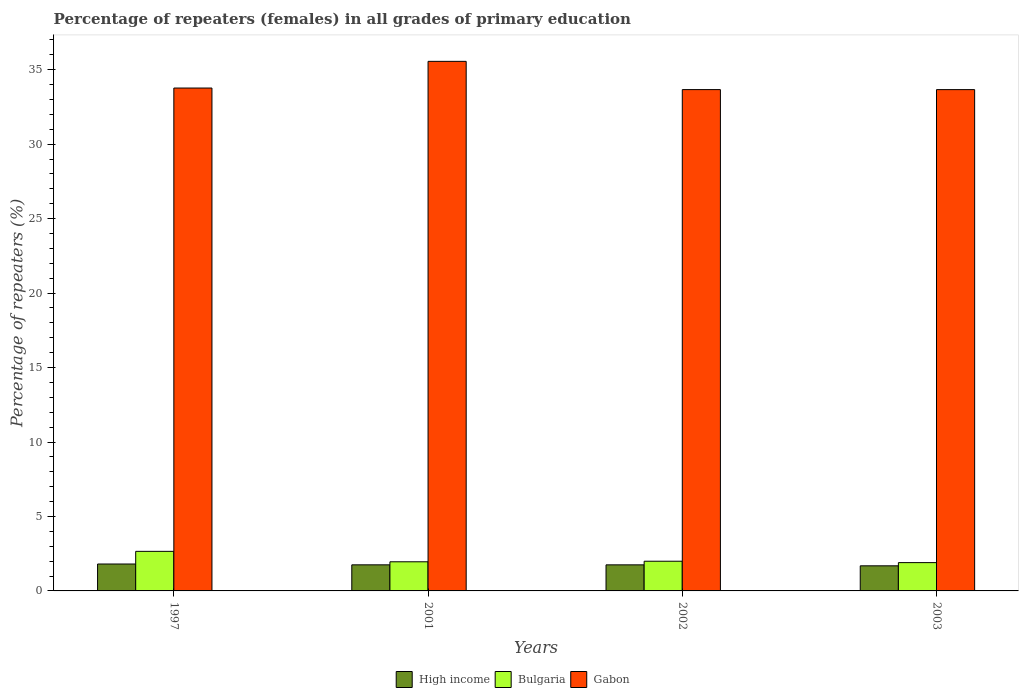How many different coloured bars are there?
Provide a succinct answer. 3. How many groups of bars are there?
Your response must be concise. 4. Are the number of bars on each tick of the X-axis equal?
Your answer should be very brief. Yes. How many bars are there on the 1st tick from the left?
Your answer should be compact. 3. What is the label of the 1st group of bars from the left?
Your answer should be very brief. 1997. What is the percentage of repeaters (females) in Gabon in 2002?
Ensure brevity in your answer.  33.66. Across all years, what is the maximum percentage of repeaters (females) in Bulgaria?
Provide a short and direct response. 2.66. Across all years, what is the minimum percentage of repeaters (females) in Bulgaria?
Provide a succinct answer. 1.9. In which year was the percentage of repeaters (females) in Bulgaria maximum?
Provide a short and direct response. 1997. In which year was the percentage of repeaters (females) in Gabon minimum?
Offer a very short reply. 2003. What is the total percentage of repeaters (females) in High income in the graph?
Provide a succinct answer. 6.99. What is the difference between the percentage of repeaters (females) in Bulgaria in 2001 and that in 2003?
Provide a short and direct response. 0.06. What is the difference between the percentage of repeaters (females) in Gabon in 1997 and the percentage of repeaters (females) in Bulgaria in 2002?
Offer a terse response. 31.77. What is the average percentage of repeaters (females) in Gabon per year?
Offer a terse response. 34.16. In the year 1997, what is the difference between the percentage of repeaters (females) in Bulgaria and percentage of repeaters (females) in High income?
Your answer should be very brief. 0.85. In how many years, is the percentage of repeaters (females) in Bulgaria greater than 9 %?
Offer a terse response. 0. What is the ratio of the percentage of repeaters (females) in Bulgaria in 1997 to that in 2002?
Provide a succinct answer. 1.33. Is the percentage of repeaters (females) in Bulgaria in 2001 less than that in 2003?
Your answer should be very brief. No. What is the difference between the highest and the second highest percentage of repeaters (females) in Gabon?
Ensure brevity in your answer.  1.79. What is the difference between the highest and the lowest percentage of repeaters (females) in Gabon?
Keep it short and to the point. 1.9. In how many years, is the percentage of repeaters (females) in Gabon greater than the average percentage of repeaters (females) in Gabon taken over all years?
Make the answer very short. 1. Is the sum of the percentage of repeaters (females) in Gabon in 2001 and 2002 greater than the maximum percentage of repeaters (females) in Bulgaria across all years?
Provide a short and direct response. Yes. What does the 3rd bar from the left in 2002 represents?
Provide a short and direct response. Gabon. What does the 1st bar from the right in 2002 represents?
Give a very brief answer. Gabon. Are all the bars in the graph horizontal?
Offer a very short reply. No. What is the difference between two consecutive major ticks on the Y-axis?
Your answer should be very brief. 5. Are the values on the major ticks of Y-axis written in scientific E-notation?
Provide a succinct answer. No. Does the graph contain grids?
Keep it short and to the point. No. What is the title of the graph?
Ensure brevity in your answer.  Percentage of repeaters (females) in all grades of primary education. What is the label or title of the Y-axis?
Offer a very short reply. Percentage of repeaters (%). What is the Percentage of repeaters (%) in High income in 1997?
Your answer should be very brief. 1.81. What is the Percentage of repeaters (%) in Bulgaria in 1997?
Your answer should be compact. 2.66. What is the Percentage of repeaters (%) in Gabon in 1997?
Offer a terse response. 33.77. What is the Percentage of repeaters (%) of High income in 2001?
Your response must be concise. 1.75. What is the Percentage of repeaters (%) in Bulgaria in 2001?
Provide a succinct answer. 1.96. What is the Percentage of repeaters (%) of Gabon in 2001?
Provide a short and direct response. 35.56. What is the Percentage of repeaters (%) in High income in 2002?
Give a very brief answer. 1.75. What is the Percentage of repeaters (%) in Bulgaria in 2002?
Offer a terse response. 1.99. What is the Percentage of repeaters (%) in Gabon in 2002?
Make the answer very short. 33.66. What is the Percentage of repeaters (%) in High income in 2003?
Offer a terse response. 1.69. What is the Percentage of repeaters (%) in Bulgaria in 2003?
Make the answer very short. 1.9. What is the Percentage of repeaters (%) of Gabon in 2003?
Make the answer very short. 33.66. Across all years, what is the maximum Percentage of repeaters (%) of High income?
Provide a short and direct response. 1.81. Across all years, what is the maximum Percentage of repeaters (%) of Bulgaria?
Give a very brief answer. 2.66. Across all years, what is the maximum Percentage of repeaters (%) of Gabon?
Offer a terse response. 35.56. Across all years, what is the minimum Percentage of repeaters (%) of High income?
Give a very brief answer. 1.69. Across all years, what is the minimum Percentage of repeaters (%) in Bulgaria?
Offer a terse response. 1.9. Across all years, what is the minimum Percentage of repeaters (%) in Gabon?
Your answer should be compact. 33.66. What is the total Percentage of repeaters (%) of High income in the graph?
Your response must be concise. 6.99. What is the total Percentage of repeaters (%) of Bulgaria in the graph?
Provide a short and direct response. 8.51. What is the total Percentage of repeaters (%) of Gabon in the graph?
Provide a short and direct response. 136.66. What is the difference between the Percentage of repeaters (%) of High income in 1997 and that in 2001?
Keep it short and to the point. 0.06. What is the difference between the Percentage of repeaters (%) in Bulgaria in 1997 and that in 2001?
Your answer should be very brief. 0.7. What is the difference between the Percentage of repeaters (%) of Gabon in 1997 and that in 2001?
Offer a terse response. -1.79. What is the difference between the Percentage of repeaters (%) in High income in 1997 and that in 2002?
Your answer should be compact. 0.06. What is the difference between the Percentage of repeaters (%) of Bulgaria in 1997 and that in 2002?
Your answer should be very brief. 0.66. What is the difference between the Percentage of repeaters (%) of Gabon in 1997 and that in 2002?
Offer a terse response. 0.1. What is the difference between the Percentage of repeaters (%) of High income in 1997 and that in 2003?
Make the answer very short. 0.12. What is the difference between the Percentage of repeaters (%) of Bulgaria in 1997 and that in 2003?
Offer a very short reply. 0.76. What is the difference between the Percentage of repeaters (%) of Gabon in 1997 and that in 2003?
Keep it short and to the point. 0.11. What is the difference between the Percentage of repeaters (%) of High income in 2001 and that in 2002?
Make the answer very short. 0. What is the difference between the Percentage of repeaters (%) of Bulgaria in 2001 and that in 2002?
Your answer should be compact. -0.04. What is the difference between the Percentage of repeaters (%) of Gabon in 2001 and that in 2002?
Offer a very short reply. 1.9. What is the difference between the Percentage of repeaters (%) in High income in 2001 and that in 2003?
Offer a terse response. 0.07. What is the difference between the Percentage of repeaters (%) in Bulgaria in 2001 and that in 2003?
Offer a terse response. 0.06. What is the difference between the Percentage of repeaters (%) of Gabon in 2001 and that in 2003?
Give a very brief answer. 1.9. What is the difference between the Percentage of repeaters (%) of High income in 2002 and that in 2003?
Offer a terse response. 0.06. What is the difference between the Percentage of repeaters (%) of Bulgaria in 2002 and that in 2003?
Your response must be concise. 0.09. What is the difference between the Percentage of repeaters (%) in Gabon in 2002 and that in 2003?
Offer a very short reply. 0. What is the difference between the Percentage of repeaters (%) in High income in 1997 and the Percentage of repeaters (%) in Bulgaria in 2001?
Ensure brevity in your answer.  -0.15. What is the difference between the Percentage of repeaters (%) of High income in 1997 and the Percentage of repeaters (%) of Gabon in 2001?
Give a very brief answer. -33.75. What is the difference between the Percentage of repeaters (%) of Bulgaria in 1997 and the Percentage of repeaters (%) of Gabon in 2001?
Your answer should be very brief. -32.9. What is the difference between the Percentage of repeaters (%) in High income in 1997 and the Percentage of repeaters (%) in Bulgaria in 2002?
Your answer should be compact. -0.19. What is the difference between the Percentage of repeaters (%) in High income in 1997 and the Percentage of repeaters (%) in Gabon in 2002?
Your answer should be compact. -31.86. What is the difference between the Percentage of repeaters (%) in Bulgaria in 1997 and the Percentage of repeaters (%) in Gabon in 2002?
Your answer should be compact. -31.01. What is the difference between the Percentage of repeaters (%) in High income in 1997 and the Percentage of repeaters (%) in Bulgaria in 2003?
Make the answer very short. -0.09. What is the difference between the Percentage of repeaters (%) in High income in 1997 and the Percentage of repeaters (%) in Gabon in 2003?
Offer a very short reply. -31.86. What is the difference between the Percentage of repeaters (%) in Bulgaria in 1997 and the Percentage of repeaters (%) in Gabon in 2003?
Keep it short and to the point. -31.01. What is the difference between the Percentage of repeaters (%) of High income in 2001 and the Percentage of repeaters (%) of Bulgaria in 2002?
Offer a very short reply. -0.24. What is the difference between the Percentage of repeaters (%) in High income in 2001 and the Percentage of repeaters (%) in Gabon in 2002?
Offer a terse response. -31.91. What is the difference between the Percentage of repeaters (%) of Bulgaria in 2001 and the Percentage of repeaters (%) of Gabon in 2002?
Make the answer very short. -31.71. What is the difference between the Percentage of repeaters (%) of High income in 2001 and the Percentage of repeaters (%) of Bulgaria in 2003?
Make the answer very short. -0.15. What is the difference between the Percentage of repeaters (%) of High income in 2001 and the Percentage of repeaters (%) of Gabon in 2003?
Your answer should be compact. -31.91. What is the difference between the Percentage of repeaters (%) of Bulgaria in 2001 and the Percentage of repeaters (%) of Gabon in 2003?
Provide a succinct answer. -31.71. What is the difference between the Percentage of repeaters (%) of High income in 2002 and the Percentage of repeaters (%) of Bulgaria in 2003?
Your answer should be compact. -0.15. What is the difference between the Percentage of repeaters (%) in High income in 2002 and the Percentage of repeaters (%) in Gabon in 2003?
Give a very brief answer. -31.91. What is the difference between the Percentage of repeaters (%) in Bulgaria in 2002 and the Percentage of repeaters (%) in Gabon in 2003?
Ensure brevity in your answer.  -31.67. What is the average Percentage of repeaters (%) of High income per year?
Make the answer very short. 1.75. What is the average Percentage of repeaters (%) of Bulgaria per year?
Your answer should be compact. 2.13. What is the average Percentage of repeaters (%) of Gabon per year?
Ensure brevity in your answer.  34.16. In the year 1997, what is the difference between the Percentage of repeaters (%) of High income and Percentage of repeaters (%) of Bulgaria?
Offer a terse response. -0.85. In the year 1997, what is the difference between the Percentage of repeaters (%) in High income and Percentage of repeaters (%) in Gabon?
Your answer should be compact. -31.96. In the year 1997, what is the difference between the Percentage of repeaters (%) in Bulgaria and Percentage of repeaters (%) in Gabon?
Provide a succinct answer. -31.11. In the year 2001, what is the difference between the Percentage of repeaters (%) in High income and Percentage of repeaters (%) in Bulgaria?
Your answer should be compact. -0.2. In the year 2001, what is the difference between the Percentage of repeaters (%) of High income and Percentage of repeaters (%) of Gabon?
Your answer should be compact. -33.81. In the year 2001, what is the difference between the Percentage of repeaters (%) of Bulgaria and Percentage of repeaters (%) of Gabon?
Keep it short and to the point. -33.6. In the year 2002, what is the difference between the Percentage of repeaters (%) of High income and Percentage of repeaters (%) of Bulgaria?
Provide a short and direct response. -0.24. In the year 2002, what is the difference between the Percentage of repeaters (%) of High income and Percentage of repeaters (%) of Gabon?
Your answer should be very brief. -31.91. In the year 2002, what is the difference between the Percentage of repeaters (%) in Bulgaria and Percentage of repeaters (%) in Gabon?
Keep it short and to the point. -31.67. In the year 2003, what is the difference between the Percentage of repeaters (%) in High income and Percentage of repeaters (%) in Bulgaria?
Give a very brief answer. -0.21. In the year 2003, what is the difference between the Percentage of repeaters (%) of High income and Percentage of repeaters (%) of Gabon?
Your response must be concise. -31.98. In the year 2003, what is the difference between the Percentage of repeaters (%) in Bulgaria and Percentage of repeaters (%) in Gabon?
Provide a succinct answer. -31.76. What is the ratio of the Percentage of repeaters (%) in High income in 1997 to that in 2001?
Provide a succinct answer. 1.03. What is the ratio of the Percentage of repeaters (%) of Bulgaria in 1997 to that in 2001?
Your response must be concise. 1.36. What is the ratio of the Percentage of repeaters (%) of Gabon in 1997 to that in 2001?
Provide a short and direct response. 0.95. What is the ratio of the Percentage of repeaters (%) in High income in 1997 to that in 2002?
Provide a short and direct response. 1.03. What is the ratio of the Percentage of repeaters (%) in Bulgaria in 1997 to that in 2002?
Give a very brief answer. 1.33. What is the ratio of the Percentage of repeaters (%) in Gabon in 1997 to that in 2002?
Offer a very short reply. 1. What is the ratio of the Percentage of repeaters (%) in High income in 1997 to that in 2003?
Make the answer very short. 1.07. What is the ratio of the Percentage of repeaters (%) in Bulgaria in 1997 to that in 2003?
Offer a terse response. 1.4. What is the ratio of the Percentage of repeaters (%) in High income in 2001 to that in 2002?
Keep it short and to the point. 1. What is the ratio of the Percentage of repeaters (%) of Gabon in 2001 to that in 2002?
Provide a succinct answer. 1.06. What is the ratio of the Percentage of repeaters (%) in High income in 2001 to that in 2003?
Your answer should be very brief. 1.04. What is the ratio of the Percentage of repeaters (%) of Bulgaria in 2001 to that in 2003?
Your answer should be very brief. 1.03. What is the ratio of the Percentage of repeaters (%) in Gabon in 2001 to that in 2003?
Your answer should be compact. 1.06. What is the ratio of the Percentage of repeaters (%) in High income in 2002 to that in 2003?
Your response must be concise. 1.04. What is the ratio of the Percentage of repeaters (%) in Bulgaria in 2002 to that in 2003?
Ensure brevity in your answer.  1.05. What is the difference between the highest and the second highest Percentage of repeaters (%) of High income?
Ensure brevity in your answer.  0.06. What is the difference between the highest and the second highest Percentage of repeaters (%) in Bulgaria?
Keep it short and to the point. 0.66. What is the difference between the highest and the second highest Percentage of repeaters (%) of Gabon?
Provide a short and direct response. 1.79. What is the difference between the highest and the lowest Percentage of repeaters (%) in High income?
Keep it short and to the point. 0.12. What is the difference between the highest and the lowest Percentage of repeaters (%) in Bulgaria?
Provide a succinct answer. 0.76. What is the difference between the highest and the lowest Percentage of repeaters (%) in Gabon?
Ensure brevity in your answer.  1.9. 